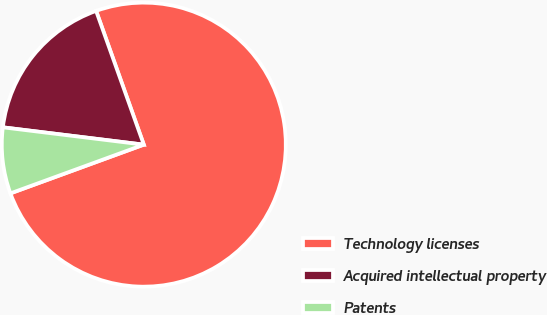Convert chart to OTSL. <chart><loc_0><loc_0><loc_500><loc_500><pie_chart><fcel>Technology licenses<fcel>Acquired intellectual property<fcel>Patents<nl><fcel>74.87%<fcel>17.6%<fcel>7.52%<nl></chart> 